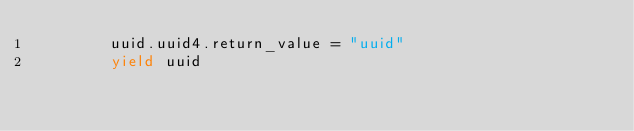Convert code to text. <code><loc_0><loc_0><loc_500><loc_500><_Python_>        uuid.uuid4.return_value = "uuid"
        yield uuid
</code> 